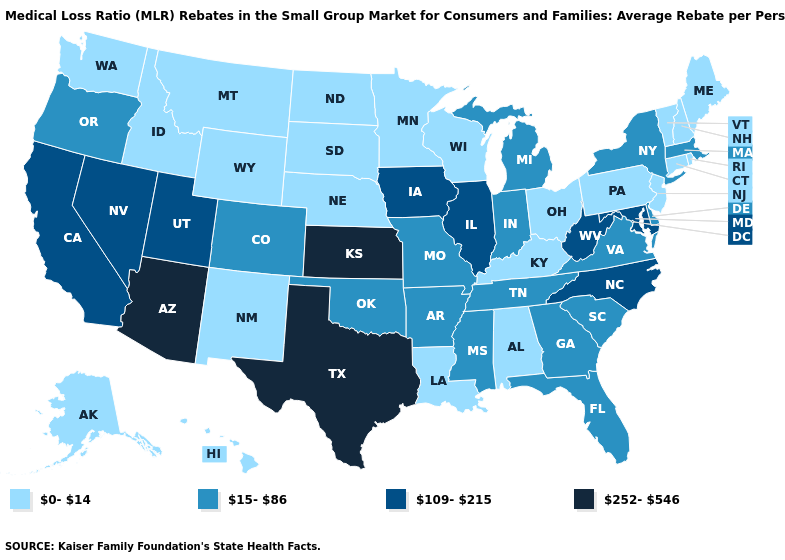Name the states that have a value in the range 0-14?
Be succinct. Alabama, Alaska, Connecticut, Hawaii, Idaho, Kentucky, Louisiana, Maine, Minnesota, Montana, Nebraska, New Hampshire, New Jersey, New Mexico, North Dakota, Ohio, Pennsylvania, Rhode Island, South Dakota, Vermont, Washington, Wisconsin, Wyoming. What is the value of Nevada?
Be succinct. 109-215. What is the highest value in the USA?
Keep it brief. 252-546. What is the value of Rhode Island?
Answer briefly. 0-14. What is the lowest value in the South?
Concise answer only. 0-14. Name the states that have a value in the range 109-215?
Concise answer only. California, Illinois, Iowa, Maryland, Nevada, North Carolina, Utah, West Virginia. Name the states that have a value in the range 252-546?
Concise answer only. Arizona, Kansas, Texas. What is the value of Nevada?
Answer briefly. 109-215. Among the states that border North Dakota , which have the highest value?
Short answer required. Minnesota, Montana, South Dakota. Name the states that have a value in the range 0-14?
Answer briefly. Alabama, Alaska, Connecticut, Hawaii, Idaho, Kentucky, Louisiana, Maine, Minnesota, Montana, Nebraska, New Hampshire, New Jersey, New Mexico, North Dakota, Ohio, Pennsylvania, Rhode Island, South Dakota, Vermont, Washington, Wisconsin, Wyoming. What is the value of Colorado?
Give a very brief answer. 15-86. Among the states that border Georgia , does Florida have the highest value?
Answer briefly. No. What is the lowest value in states that border Ohio?
Write a very short answer. 0-14. What is the lowest value in the West?
Answer briefly. 0-14. Does the first symbol in the legend represent the smallest category?
Quick response, please. Yes. 